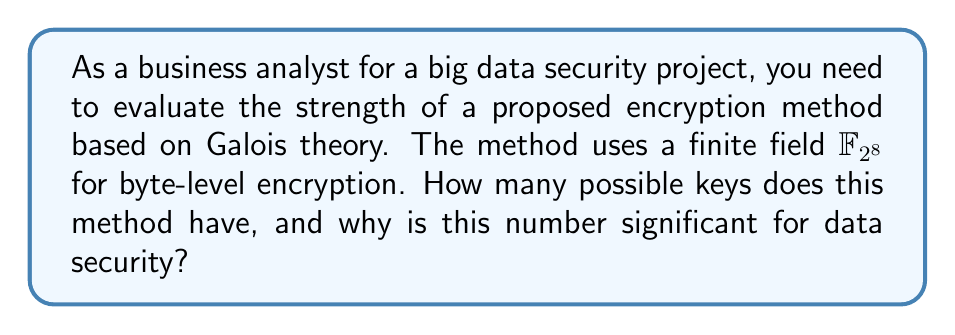What is the answer to this math problem? To answer this question, we'll follow these steps:

1) In Galois theory, a finite field $\mathbb{F}_{2^n}$ has $2^n$ elements.

2) In this case, we're using $\mathbb{F}_{2^8}$, so:
   $$|\mathbb{F}_{2^8}| = 2^8 = 256$$

3) Each element in this field can be represented by a byte (8 bits).

4) For encryption, we typically use a primitive element of the field as the base for the key. The number of primitive elements in $\mathbb{F}_{2^n}$ is given by Euler's totient function $\phi(2^n - 1)$.

5) For $\mathbb{F}_{2^8}$, we need to calculate $\phi(2^8 - 1) = \phi(255)$:
   
   $255 = 3 \times 5 \times 17$
   
   $\phi(255) = \phi(3) \times \phi(5) \times \phi(17)$
               $= 2 \times 4 \times 16$
               $= 128$

6) This means there are 128 possible primitive elements that can be used as the base for the key.

7) The key space is then $256 \times 128 = 32,768$, as we can choose any of the 256 elements as the power for any of the 128 primitive bases.

The significance of this number for data security:
- 32,768 keys might seem like a lot, but in modern cryptography, this is considered a very small key space.
- For comparison, AES-128 has $2^{128}$ possible keys, which is astronomically larger.
- A small key space makes the encryption vulnerable to brute-force attacks, where an attacker tries all possible keys.
- In big data applications, where vast amounts of sensitive information are processed, such a small key space would be considered inadequate for ensuring data security.
Answer: 32,768 keys; inadequate for big data security due to small key space vulnerable to brute-force attacks. 